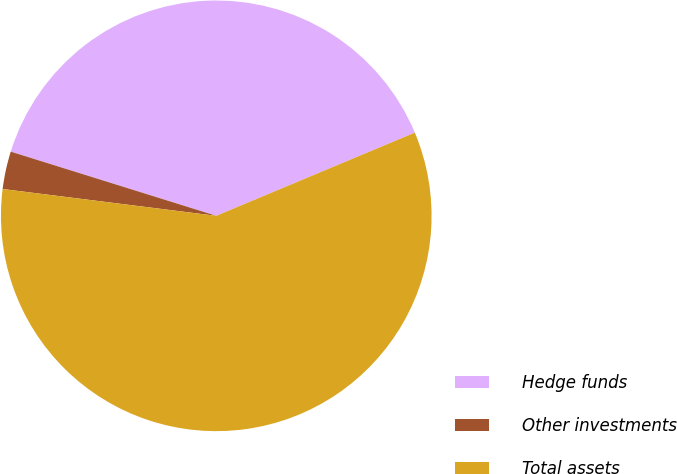Convert chart. <chart><loc_0><loc_0><loc_500><loc_500><pie_chart><fcel>Hedge funds<fcel>Other investments<fcel>Total assets<nl><fcel>38.87%<fcel>2.83%<fcel>58.3%<nl></chart> 